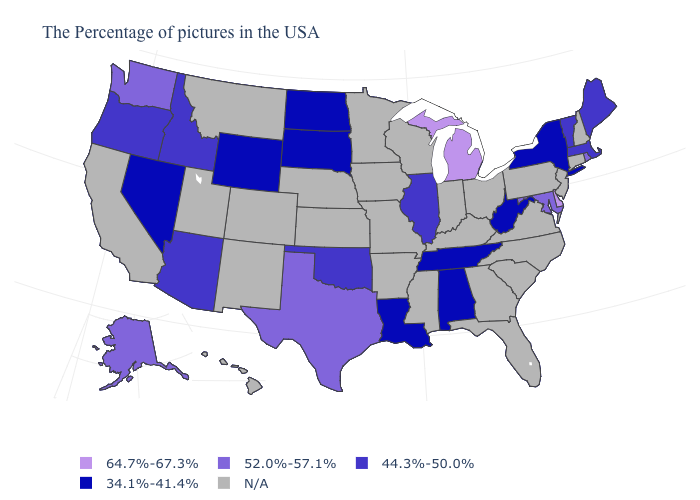What is the value of Hawaii?
Give a very brief answer. N/A. What is the value of Delaware?
Keep it brief. 64.7%-67.3%. Name the states that have a value in the range 52.0%-57.1%?
Be succinct. Rhode Island, Maryland, Texas, Washington, Alaska. Name the states that have a value in the range N/A?
Quick response, please. New Hampshire, Connecticut, New Jersey, Pennsylvania, Virginia, North Carolina, South Carolina, Ohio, Florida, Georgia, Kentucky, Indiana, Wisconsin, Mississippi, Missouri, Arkansas, Minnesota, Iowa, Kansas, Nebraska, Colorado, New Mexico, Utah, Montana, California, Hawaii. Name the states that have a value in the range 64.7%-67.3%?
Quick response, please. Delaware, Michigan. Does Maine have the lowest value in the USA?
Keep it brief. No. Does the map have missing data?
Short answer required. Yes. Name the states that have a value in the range 52.0%-57.1%?
Keep it brief. Rhode Island, Maryland, Texas, Washington, Alaska. Does Michigan have the highest value in the USA?
Write a very short answer. Yes. Name the states that have a value in the range 44.3%-50.0%?
Write a very short answer. Maine, Massachusetts, Vermont, Illinois, Oklahoma, Arizona, Idaho, Oregon. Among the states that border New Mexico , which have the lowest value?
Answer briefly. Oklahoma, Arizona. Which states have the highest value in the USA?
Concise answer only. Delaware, Michigan. What is the value of Indiana?
Quick response, please. N/A. What is the value of Alaska?
Concise answer only. 52.0%-57.1%. 